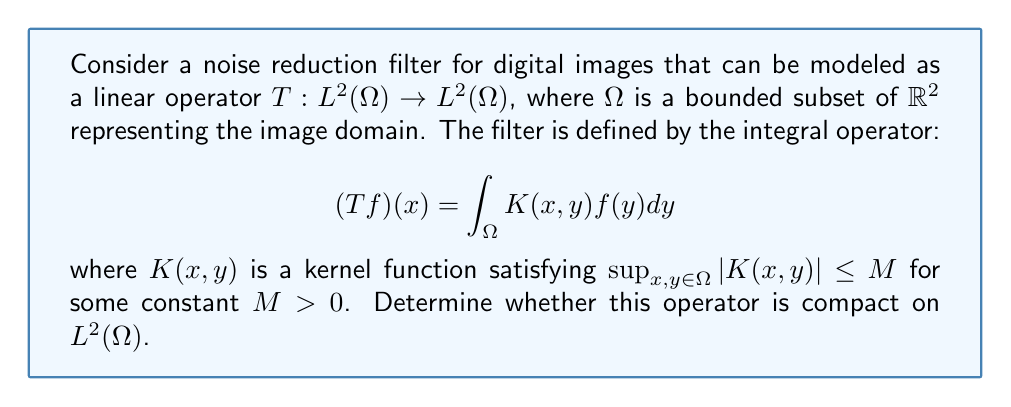Give your solution to this math problem. To determine if the operator $T$ is compact, we'll follow these steps:

1) First, recall that an operator is compact if it maps bounded sets to relatively compact sets.

2) For integral operators, we can use the Arzelà-Ascoli theorem, which states that a set of functions is relatively compact if it's uniformly bounded and equicontinuous.

3) Let's consider a bounded set $B$ in $L^2(\Omega)$. We need to show that $T(B)$ is relatively compact.

4) Uniform boundedness:
   For any $f \in B$, we have:
   $$\|Tf\|_{L^2(\Omega)}^2 = \int_\Omega |(Tf)(x)|^2 dx \leq M^2 |\Omega|^2 \|f\|_{L^2(\Omega)}^2$$
   where $|\Omega|$ is the measure of $\Omega$. This shows that $T(B)$ is uniformly bounded.

5) Equicontinuity:
   For any $f \in B$ and $x_1, x_2 \in \Omega$, we have:
   $$|(Tf)(x_1) - (Tf)(x_2)| \leq \int_\Omega |K(x_1,y) - K(x_2,y)| |f(y)| dy$$
   $$\leq \|K(x_1,\cdot) - K(x_2,\cdot)\|_{L^2(\Omega)} \|f\|_{L^2(\Omega)}$$
   
   As $x_1 \to x_2$, $\|K(x_1,\cdot) - K(x_2,\cdot)\|_{L^2(\Omega)} \to 0$ due to the continuity of $K$. This shows equicontinuity.

6) By the Arzelà-Ascoli theorem, $T(B)$ is relatively compact in $C(\Omega)$, and since $\Omega$ is bounded, it's also relatively compact in $L^2(\Omega)$.

Therefore, $T$ is a compact operator on $L^2(\Omega)$.
Answer: The noise reduction filter operator $T$ is compact on $L^2(\Omega)$. 